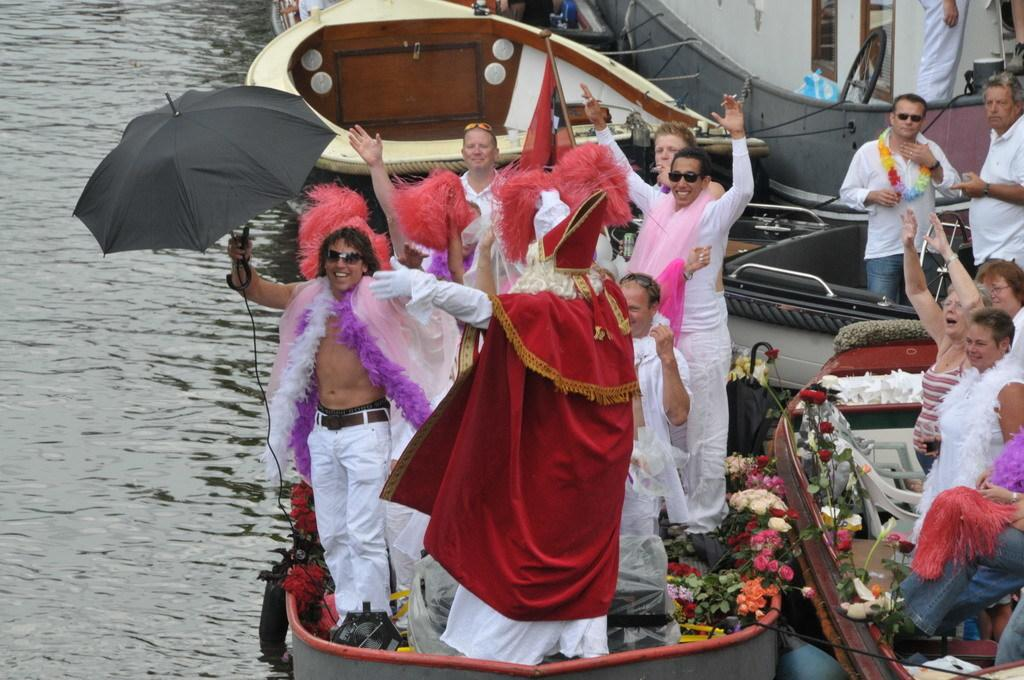Who or what can be seen in the image? There are people in the image. What are the people doing or where are they located? The people are on boats. What is the setting of the image? The boats are on water. What additional items can be seen in the image? There is an umbrella and flowers in the image. Are there any other objects present in the image? Yes, there are other objects in the image. What type of poison is being used to grow the corn in the image? There is no corn or poison present in the image. Can you tell me the name of the girl in the image? There is no girl present in the image. 